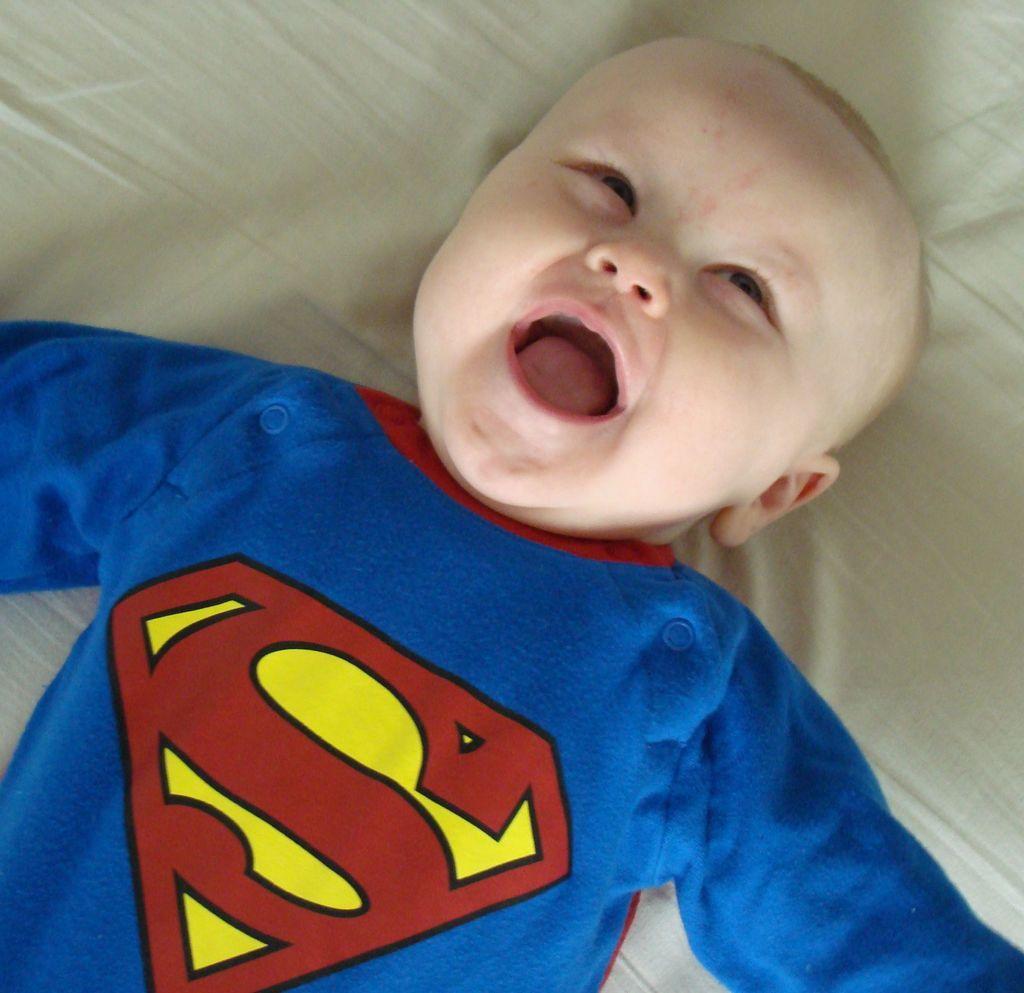Can you describe this image briefly? As we can see in the image there is a child wearing blue color dress and laying on bed. On bed there is white color bed sheet. 